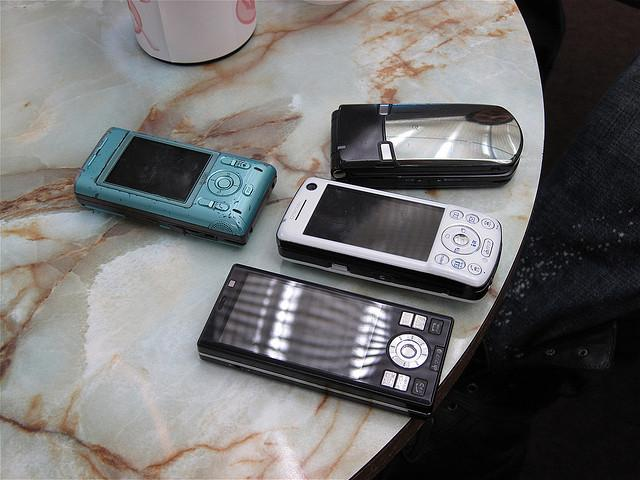What is decade are the phones most likely from? Please explain your reasoning. 1990's. The phones have a screen but they are not touch screen. most phones made now don't have a keypad. 